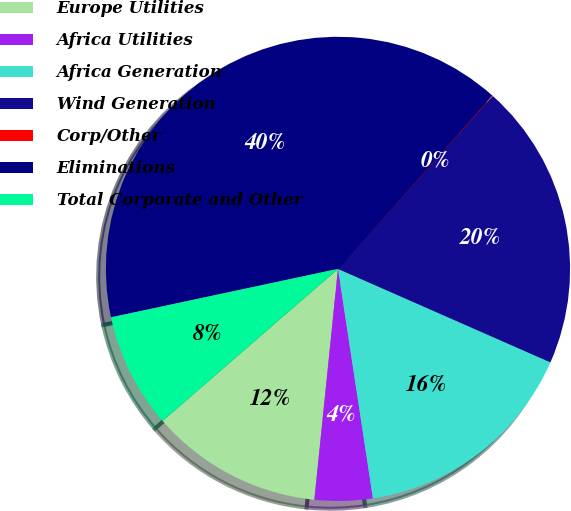Convert chart. <chart><loc_0><loc_0><loc_500><loc_500><pie_chart><fcel>Europe Utilities<fcel>Africa Utilities<fcel>Africa Generation<fcel>Wind Generation<fcel>Corp/Other<fcel>Eliminations<fcel>Total Corporate and Other<nl><fcel>12.01%<fcel>4.03%<fcel>16.0%<fcel>19.98%<fcel>0.04%<fcel>39.93%<fcel>8.02%<nl></chart> 